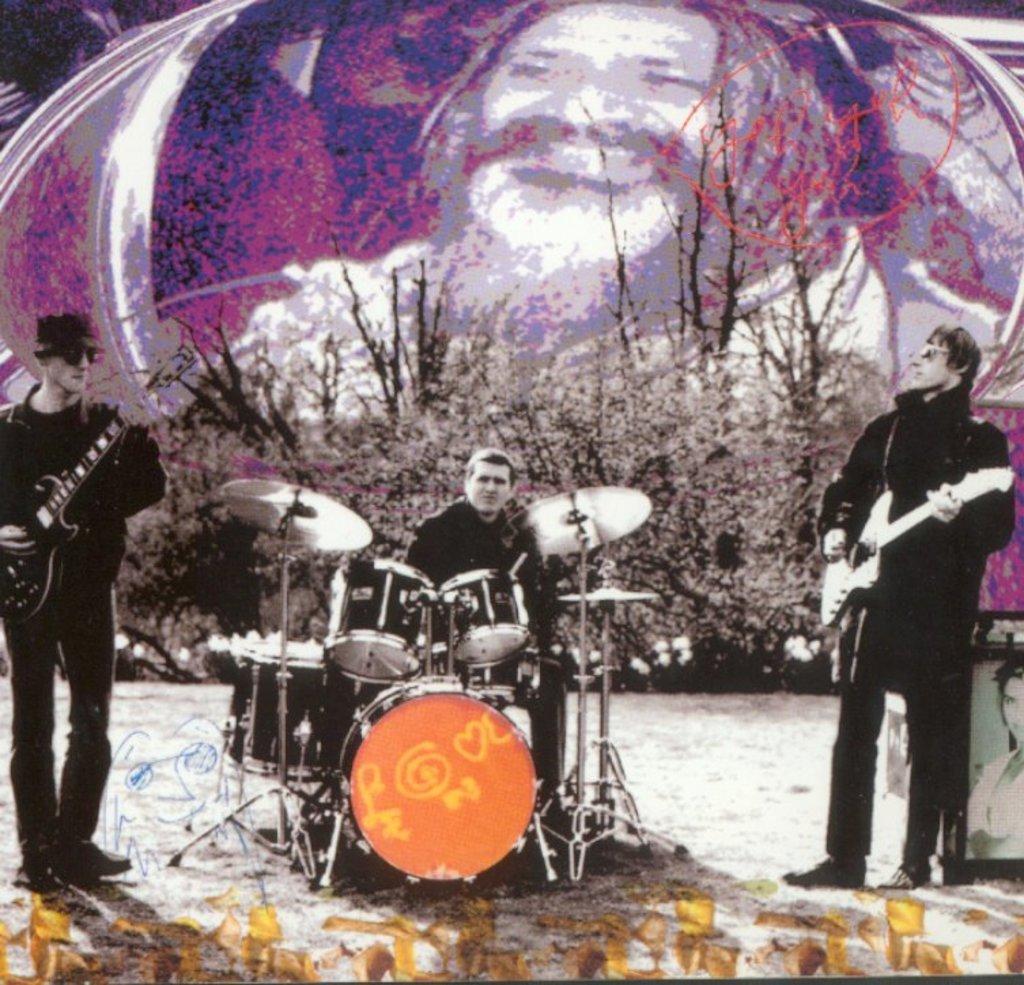In one or two sentences, can you explain what this image depicts? This person is sitting and playing this musical instruments. These 2 persons are standing and playing a guitar. These are plants. A picture on wall. 